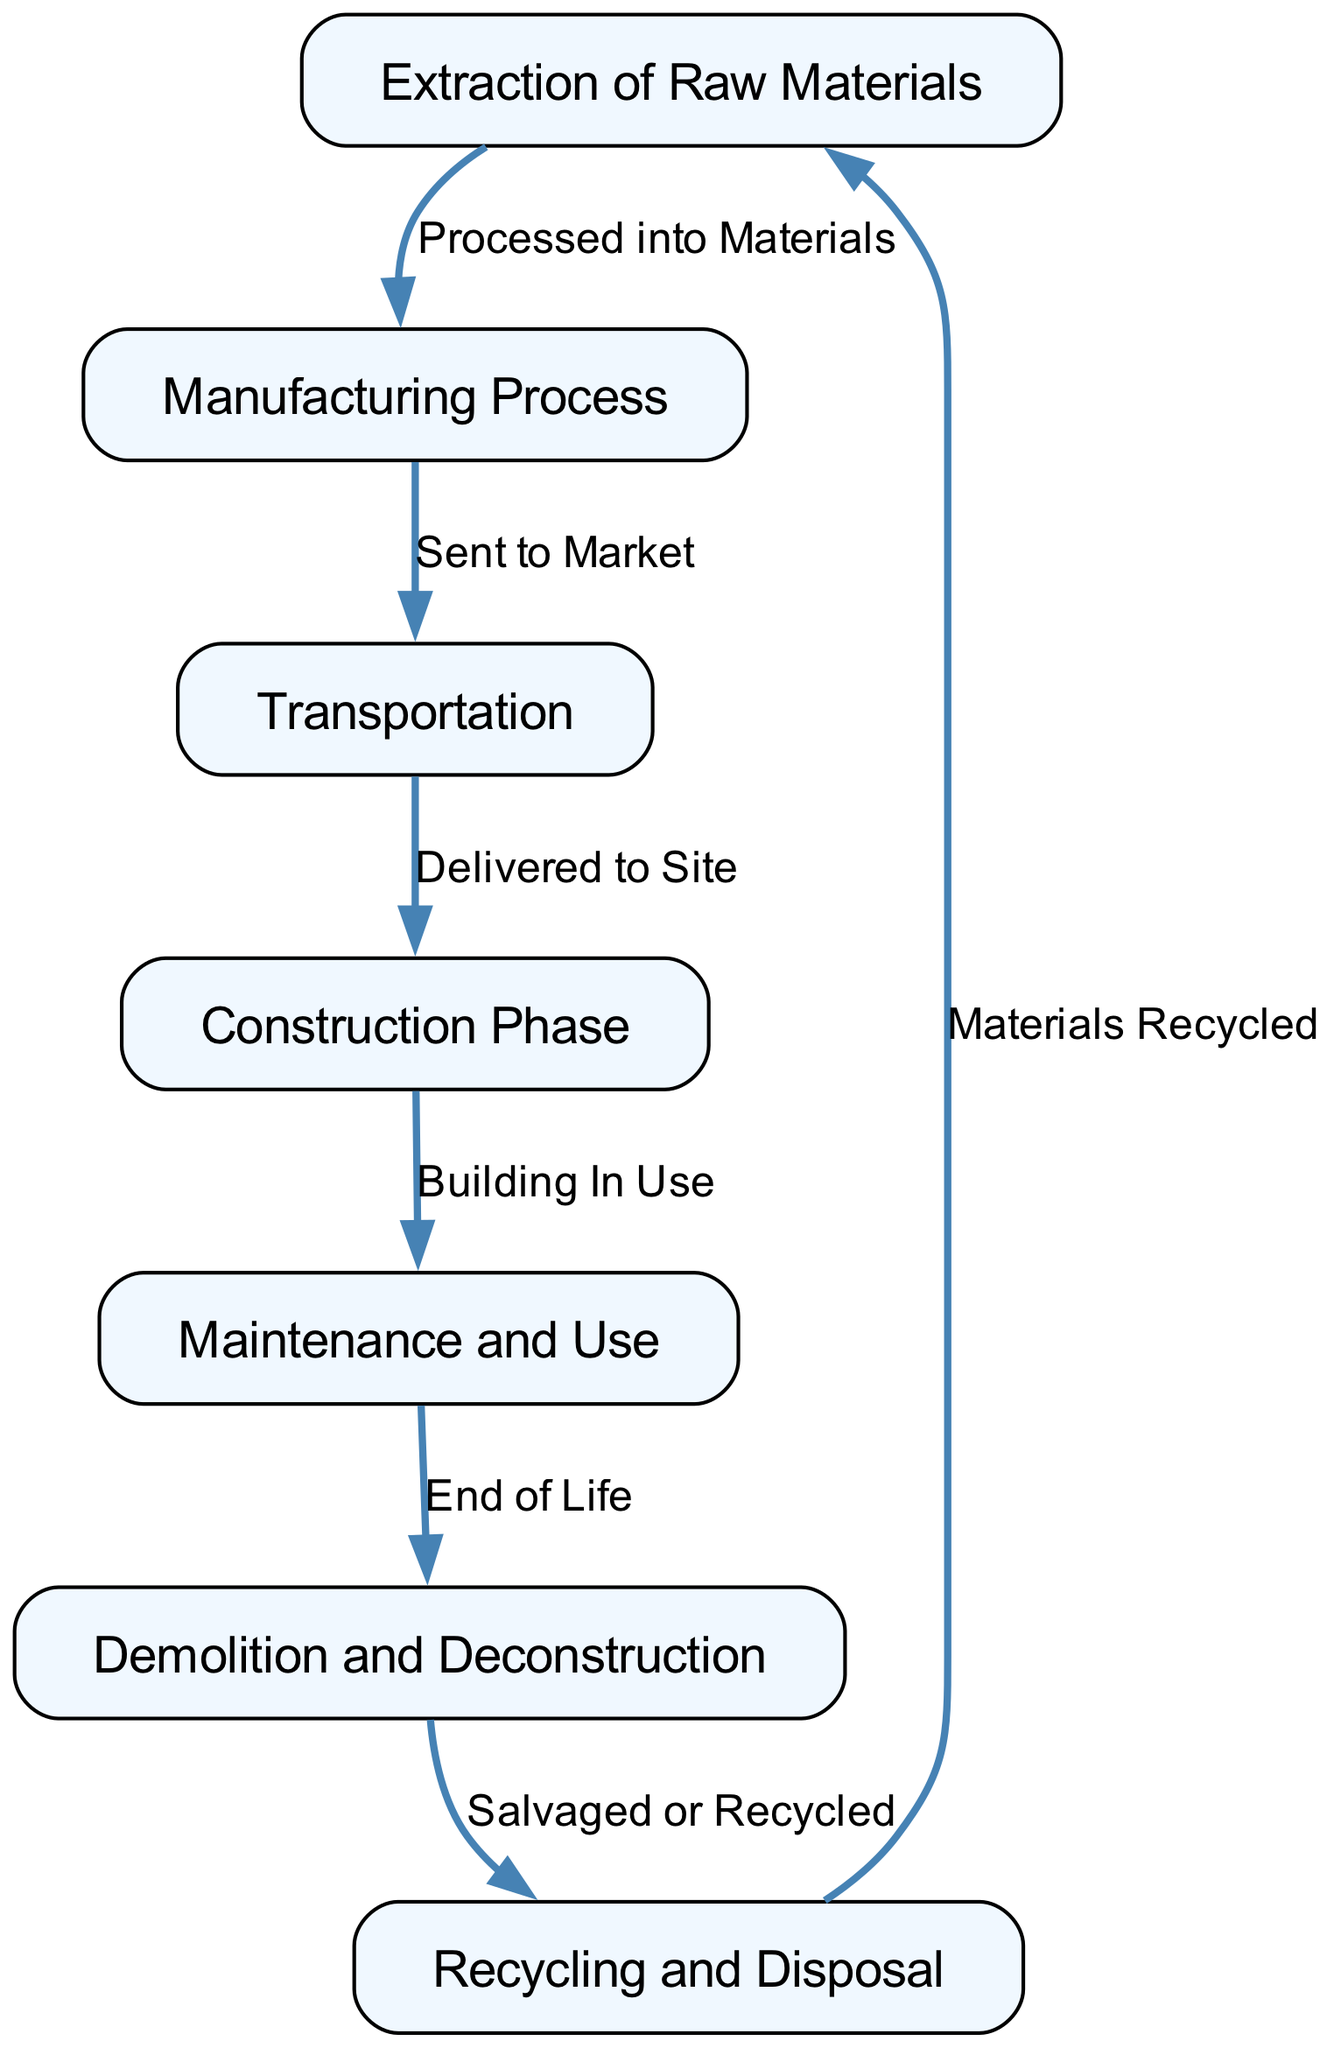What is the first step in the lifecycle of building materials? The diagram indicates that the first step is the "Extraction of Raw Materials," which is the starting point for the entire lifecycle process.
Answer: Extraction of Raw Materials How many nodes are present in the diagram? By counting the distinct steps or stages listed, there are a total of seven nodes representing different stages in the lifecycle of building materials.
Answer: 7 What is the relationship between "Manufacturing Process" and "Transportation"? The diagram shows an edge labeled "Sent to Market" connecting "Manufacturing Process" to "Transportation," indicating that after materials are manufactured, they are sent to be transported.
Answer: Sent to Market What happens after the "Construction Phase"? According to the diagram, the next step after the "Construction Phase" is "Maintenance and Use," suggesting that once a building is constructed, it enters the phase of being used and maintained.
Answer: Maintenance and Use What is the last step in the lifecycle of building materials? The final stage indicated in the diagram is "Recycling and Disposal," which represents what happens to materials at the end of their life cycle.
Answer: Recycling and Disposal Which process follows "Demolition and Deconstruction"? The diagram illustrates that after "Demolition and Deconstruction," the next step is "Recycling and Disposal," meaning that after a building is demolished, its materials are often recycled or disposed of.
Answer: Recycling and Disposal What process leads back to the "Extraction of Raw Materials"? The diagram displays an edge from "Recycling and Disposal" labeled "Materials Recycled," which indicates that some of the materials disposed of can be processed and reused, leading back to the extraction phase.
Answer: Materials Recycled 